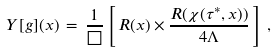Convert formula to latex. <formula><loc_0><loc_0><loc_500><loc_500>Y [ g ] ( x ) \, = \, \frac { 1 } { \square } \left [ \, R ( x ) \times \frac { R ( \chi ( \tau ^ { * } , x ) ) } { 4 \Lambda } \, \right ] \, ,</formula> 